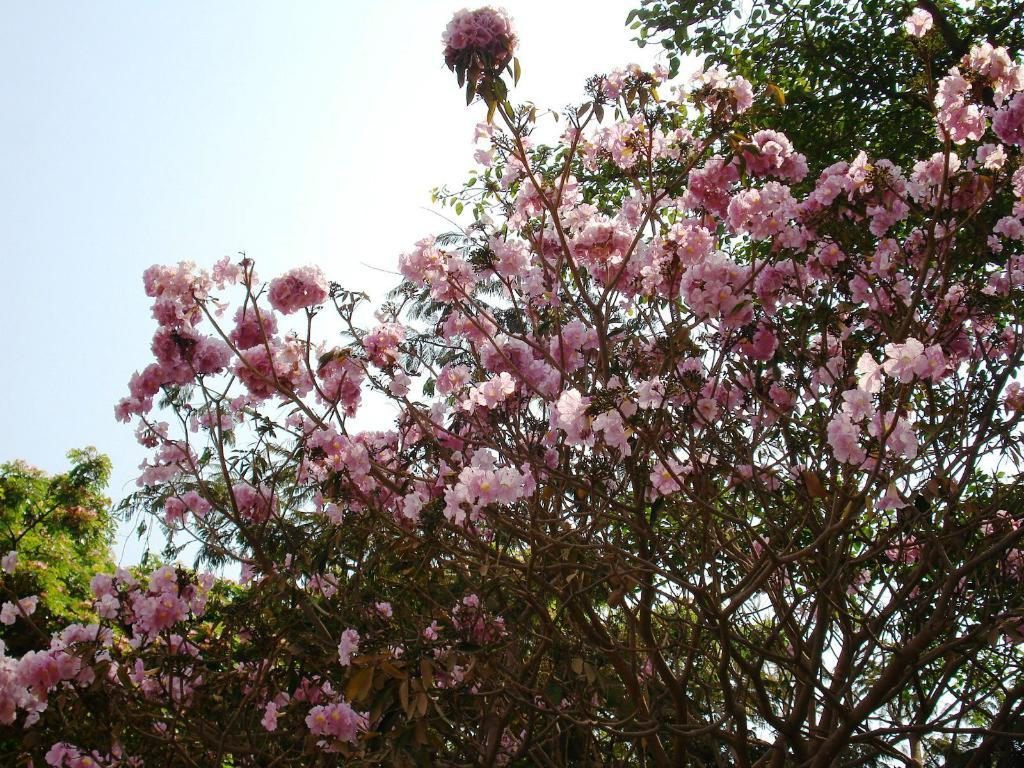What type of vegetation can be seen in the image? There are trees in the image. What other natural elements are present in the image? There are flowers in the image. What is the color of the flowers? The flowers are pink in color. What can be seen in the background of the image? The sky is visible in the background of the image. Where is the stove located in the image? There is no stove present in the image. What type of cow can be seen grazing in the image? There is no cow present in the image. 